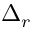Convert formula to latex. <formula><loc_0><loc_0><loc_500><loc_500>\Delta _ { r }</formula> 